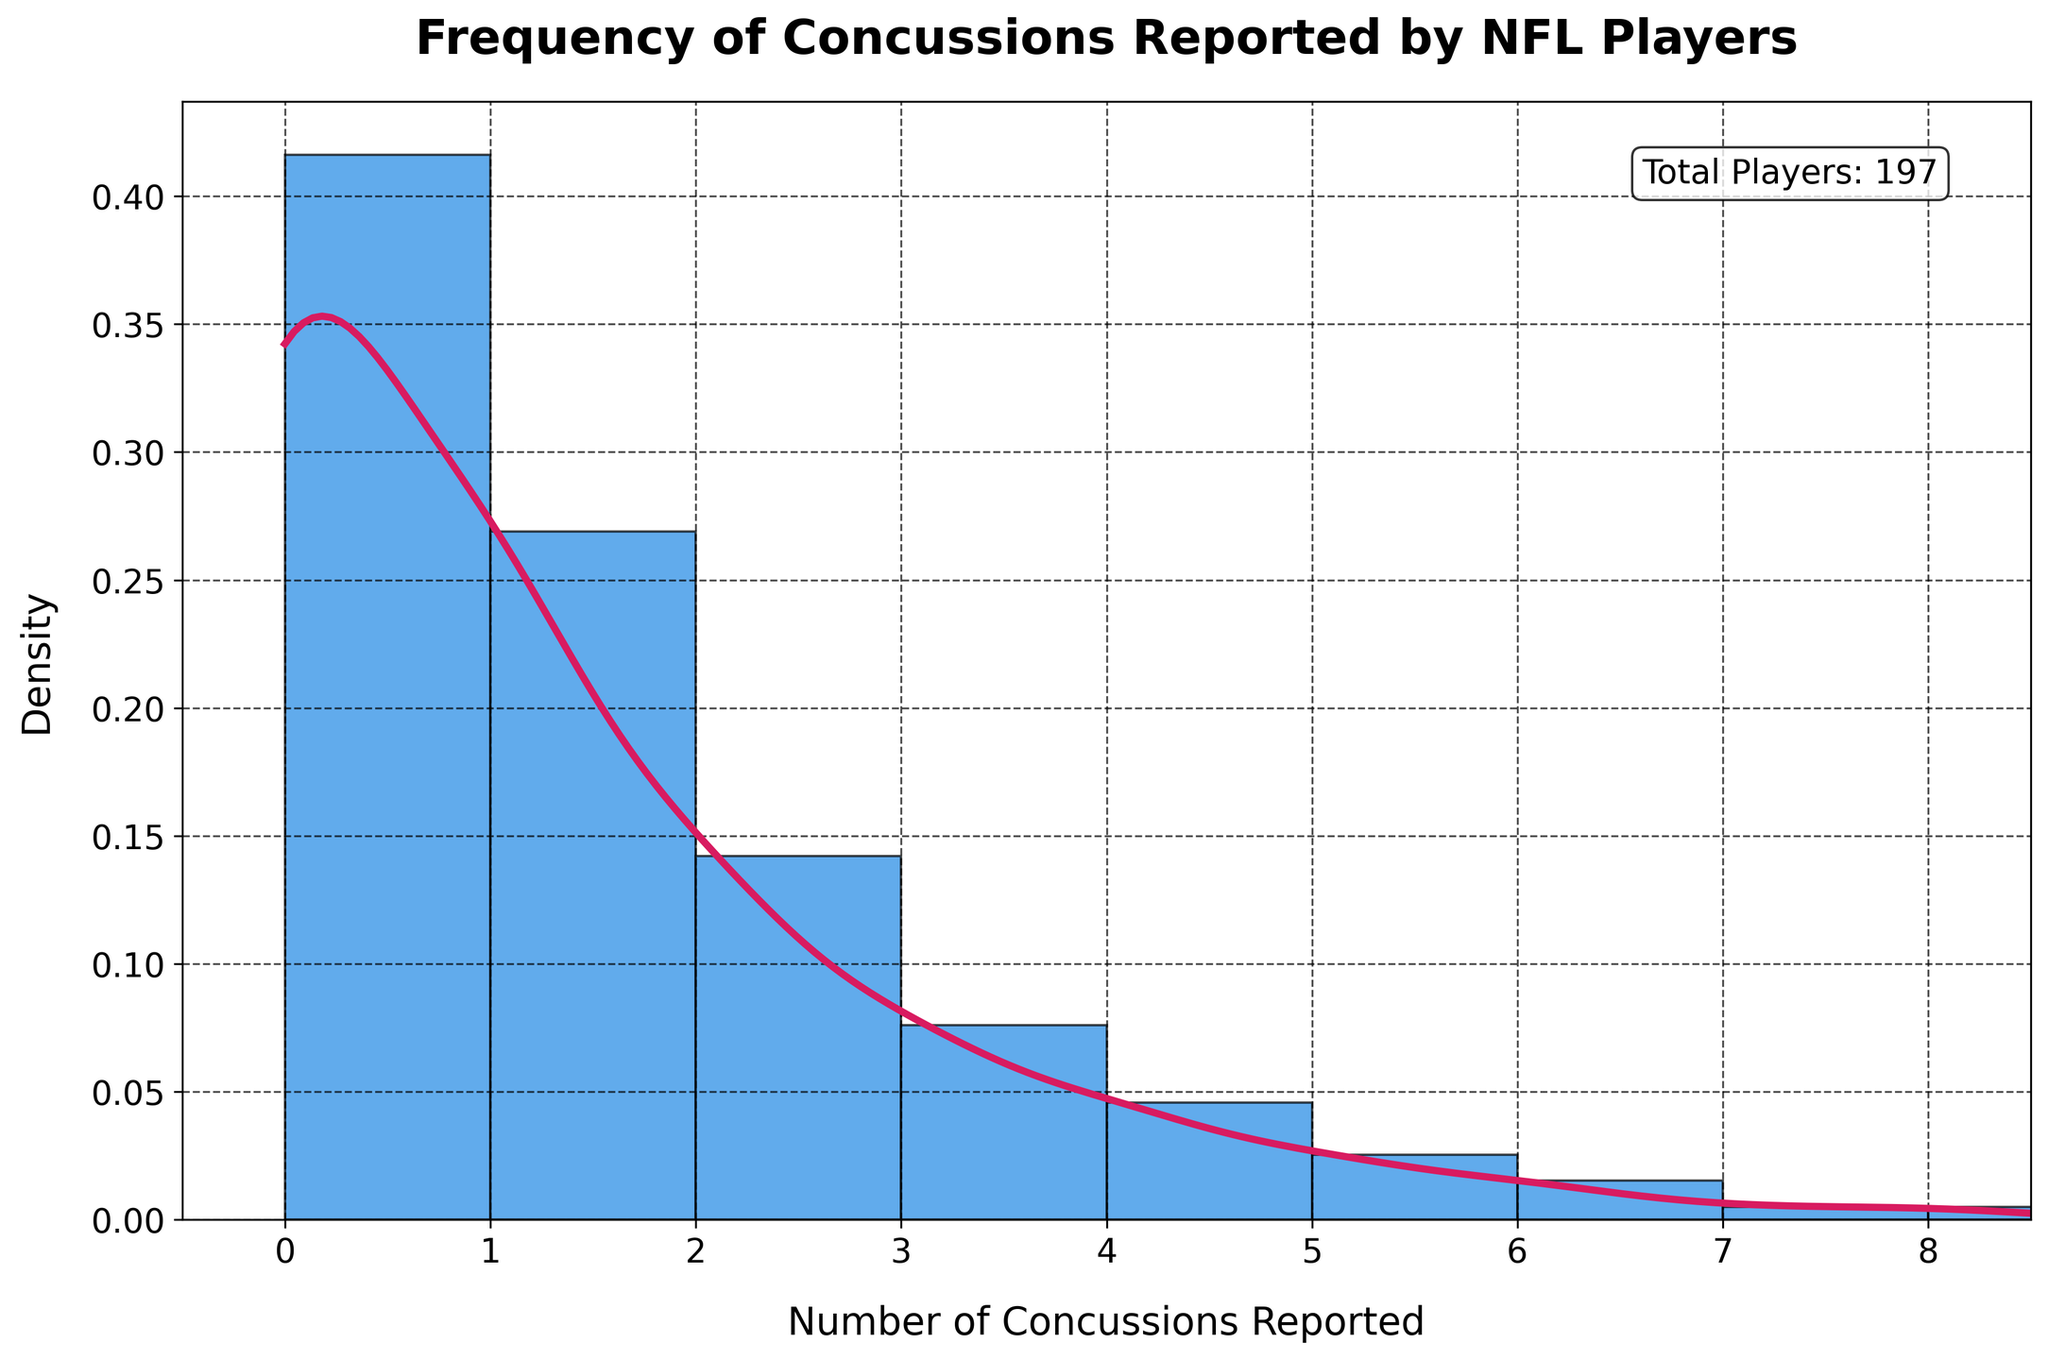what is the title of the figure? The title is prominently placed at the top of the figure, written in a bold font, making it easy to identify.
Answer: Frequency of Concussions Reported by NFL Players Where is the peak of the KDE curve? The KDE curve peaks around the point where the density is highest, visually identifiable by looking at the curve's highest point.
Answer: 0 How many players reported exactly 3 concussions? This can be read directly from the histogram bars, where the height of the bar corresponding to 3 concussions indicates the count.
Answer: 15 Which number of concussions was reported by the least number of players? The least number of players correspond to the smallest bar on the histogram. This is confirmed by checking each bar's height.
Answer: 7 and 8 (each 1 player) What is the range of the x-axis? The range on the x-axis can be determined by looking at the minimum and maximum values labeled on the axis.
Answer: 0 to 8 What is the median number of concussions reported? To find the median, identify the middle value when the data is ordered. The data mostly clusters around lower values, so you locate the middle number based on player counts.
Answer: 1 Around which number of concussions is the density the lowest, excluding 7 and 8? The lowest density after 7 and 8 can be observed by looking for the lowest point on the KDE curve, excluding those points.
Answer: 6 Compare the number of players reporting 0 concussions vs. 1 concussion. This requires comparing the heights of the bars corresponding to 0 and 1 concussions to see which is taller.
Answer: More players reported 0 concussions than 1 concussion (82 vs. 53) How does the frequency of players reporting 5 concussions compare to those reporting 4 concussions? By comparing the heights of the histogram bars for 5 and 4 concussions, you determine the relative frequencies.
Answer: Fewer players reported 5 concussions than 4 concussions What information does the text annotation provide? The annotation is placed in the figure to provide additional context or summary information, easily visible within the plot area.
Answer: Total Players: 197 